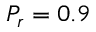Convert formula to latex. <formula><loc_0><loc_0><loc_500><loc_500>P _ { r } = 0 . 9</formula> 